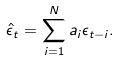Convert formula to latex. <formula><loc_0><loc_0><loc_500><loc_500>\hat { \epsilon } _ { t } = \sum _ { i = 1 } ^ { N } a _ { i } \epsilon _ { t - i } .</formula> 